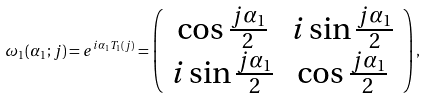<formula> <loc_0><loc_0><loc_500><loc_500>\omega _ { 1 } ( \alpha _ { 1 } ; j ) = e ^ { i \alpha _ { 1 } T _ { 1 } ( j ) } = \left ( \begin{array} { c c } \cos \frac { j \alpha _ { 1 } } { 2 } & i \sin \frac { j \alpha _ { 1 } } { 2 } \\ i \sin \frac { j \alpha _ { 1 } } { 2 } & \cos \frac { j \alpha _ { 1 } } { 2 } \end{array} \right ) ,</formula> 